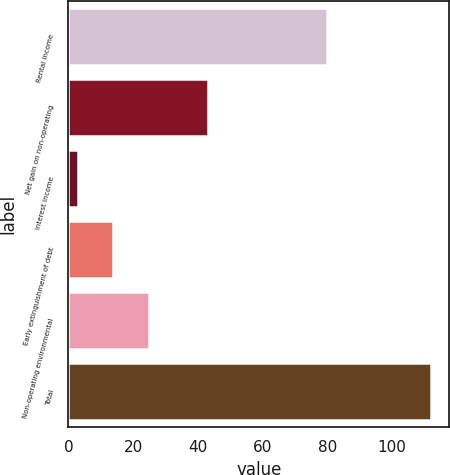Convert chart to OTSL. <chart><loc_0><loc_0><loc_500><loc_500><bar_chart><fcel>Rental income<fcel>Net gain on non-operating<fcel>Interest income<fcel>Early extinguishment of debt<fcel>Non-operating environmental<fcel>Total<nl><fcel>80<fcel>43<fcel>3<fcel>13.9<fcel>24.8<fcel>112<nl></chart> 